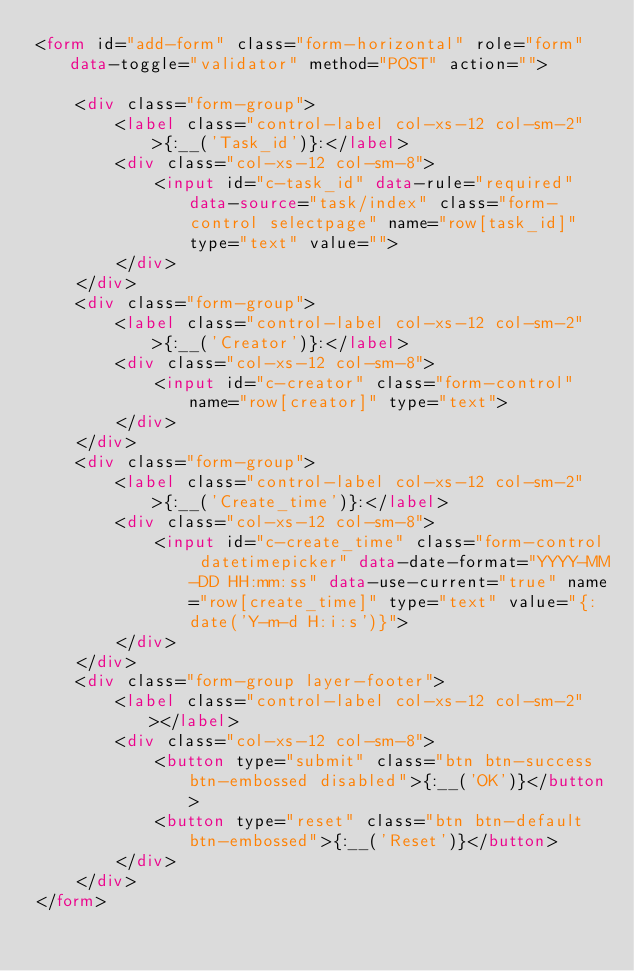<code> <loc_0><loc_0><loc_500><loc_500><_HTML_><form id="add-form" class="form-horizontal" role="form" data-toggle="validator" method="POST" action="">

    <div class="form-group">
        <label class="control-label col-xs-12 col-sm-2">{:__('Task_id')}:</label>
        <div class="col-xs-12 col-sm-8">
            <input id="c-task_id" data-rule="required" data-source="task/index" class="form-control selectpage" name="row[task_id]" type="text" value="">
        </div>
    </div>
    <div class="form-group">
        <label class="control-label col-xs-12 col-sm-2">{:__('Creator')}:</label>
        <div class="col-xs-12 col-sm-8">
            <input id="c-creator" class="form-control" name="row[creator]" type="text">
        </div>
    </div>
    <div class="form-group">
        <label class="control-label col-xs-12 col-sm-2">{:__('Create_time')}:</label>
        <div class="col-xs-12 col-sm-8">
            <input id="c-create_time" class="form-control datetimepicker" data-date-format="YYYY-MM-DD HH:mm:ss" data-use-current="true" name="row[create_time]" type="text" value="{:date('Y-m-d H:i:s')}">
        </div>
    </div>
    <div class="form-group layer-footer">
        <label class="control-label col-xs-12 col-sm-2"></label>
        <div class="col-xs-12 col-sm-8">
            <button type="submit" class="btn btn-success btn-embossed disabled">{:__('OK')}</button>
            <button type="reset" class="btn btn-default btn-embossed">{:__('Reset')}</button>
        </div>
    </div>
</form>
</code> 